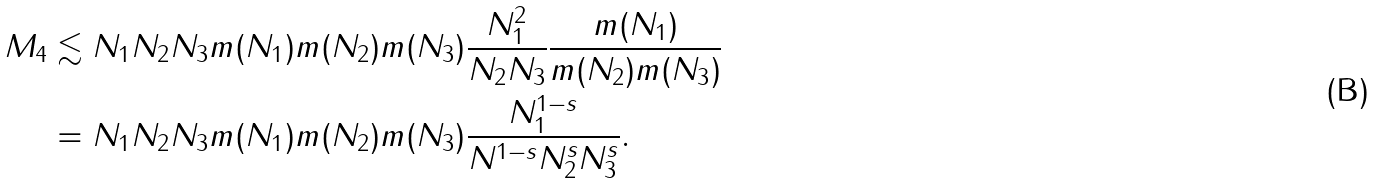<formula> <loc_0><loc_0><loc_500><loc_500>M _ { 4 } & \lesssim N _ { 1 } N _ { 2 } N _ { 3 } m ( N _ { 1 } ) m ( N _ { 2 } ) m ( N _ { 3 } ) \frac { N _ { 1 } ^ { 2 } } { N _ { 2 } N _ { 3 } } \frac { m ( N _ { 1 } ) } { m ( N _ { 2 } ) m ( N _ { 3 } ) } \\ & = N _ { 1 } N _ { 2 } N _ { 3 } m ( N _ { 1 } ) m ( N _ { 2 } ) m ( N _ { 3 } ) \frac { N _ { 1 } ^ { 1 - s } } { N ^ { 1 - s } N _ { 2 } ^ { s } N _ { 3 } ^ { s } } .</formula> 